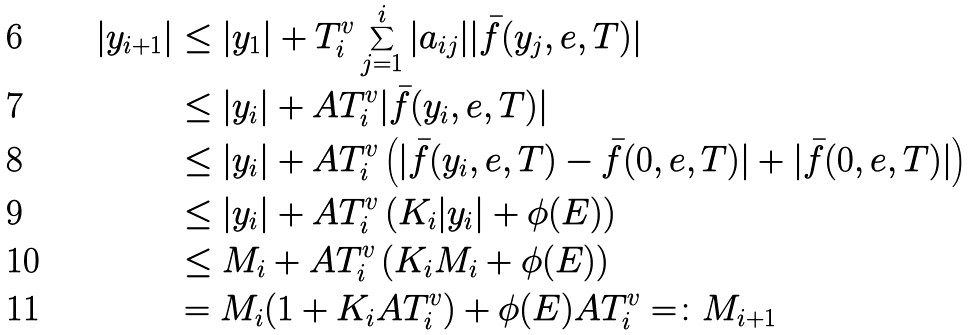<formula> <loc_0><loc_0><loc_500><loc_500>| y _ { i + 1 } | & \leq | y _ { 1 } | + T ^ { v } _ { i } \sum _ { j = 1 } ^ { i } | a _ { i j } | | \bar { f } ( y _ { j } , e , T ) | \\ & \leq | y _ { i } | + A T ^ { v } _ { i } | \bar { f } ( y _ { i } , e , T ) | \\ & \leq | y _ { i } | + A T ^ { v } _ { i } \left ( | \bar { f } ( y _ { i } , e , T ) - \bar { f } ( 0 , e , T ) | + | \bar { f } ( 0 , e , T ) | \right ) \\ & \leq | y _ { i } | + A T ^ { v } _ { i } \left ( K _ { i } | y _ { i } | + \phi ( E ) \right ) \\ & \leq M _ { i } + A T ^ { v } _ { i } \left ( K _ { i } M _ { i } + \phi ( E ) \right ) \\ & = M _ { i } ( 1 + K _ { i } A T ^ { v } _ { i } ) + \phi ( E ) A T ^ { v } _ { i } = \colon M _ { i + 1 }</formula> 